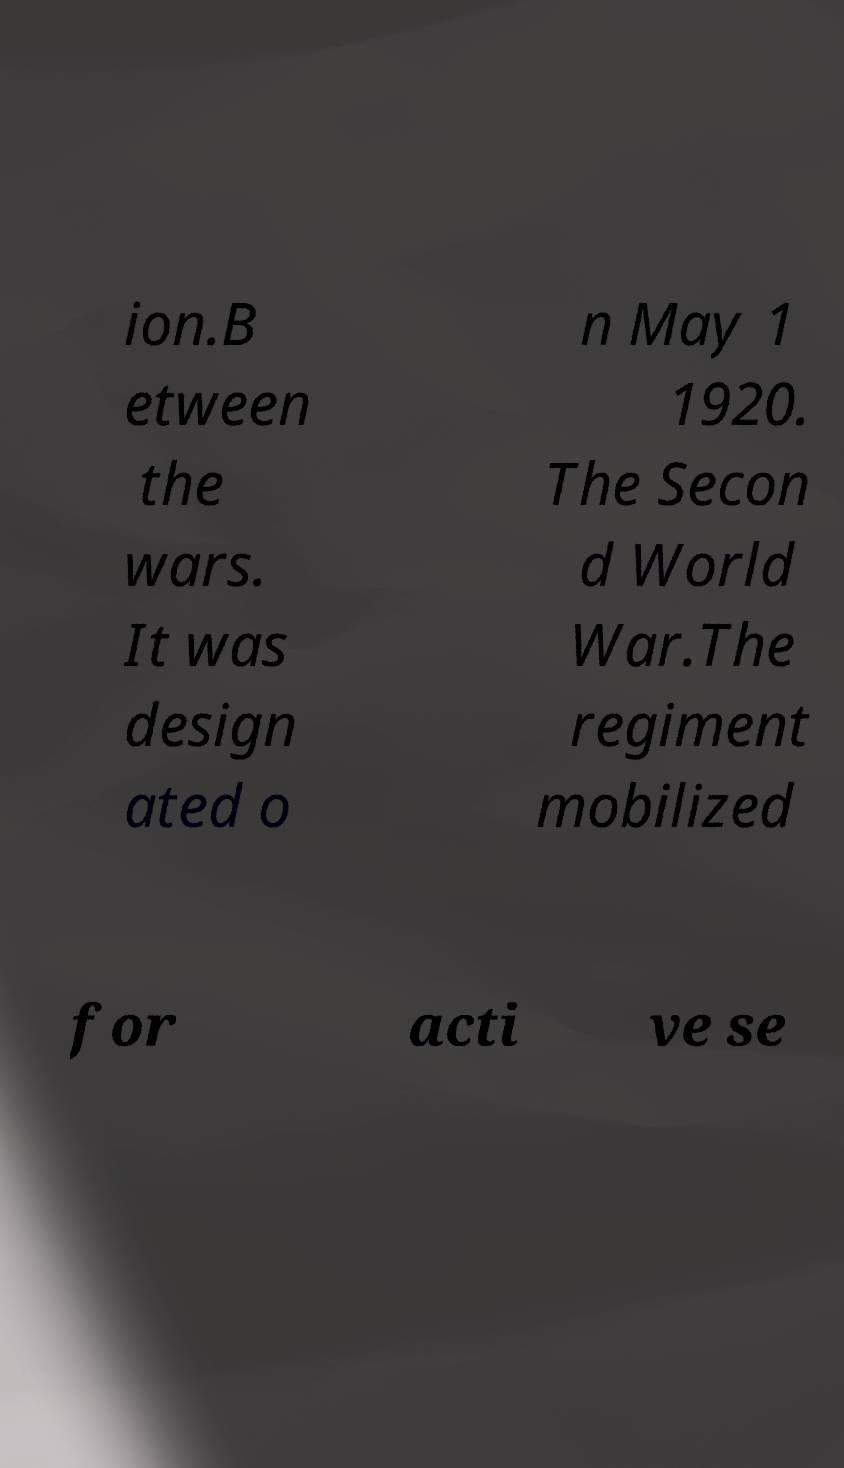There's text embedded in this image that I need extracted. Can you transcribe it verbatim? ion.B etween the wars. It was design ated o n May 1 1920. The Secon d World War.The regiment mobilized for acti ve se 